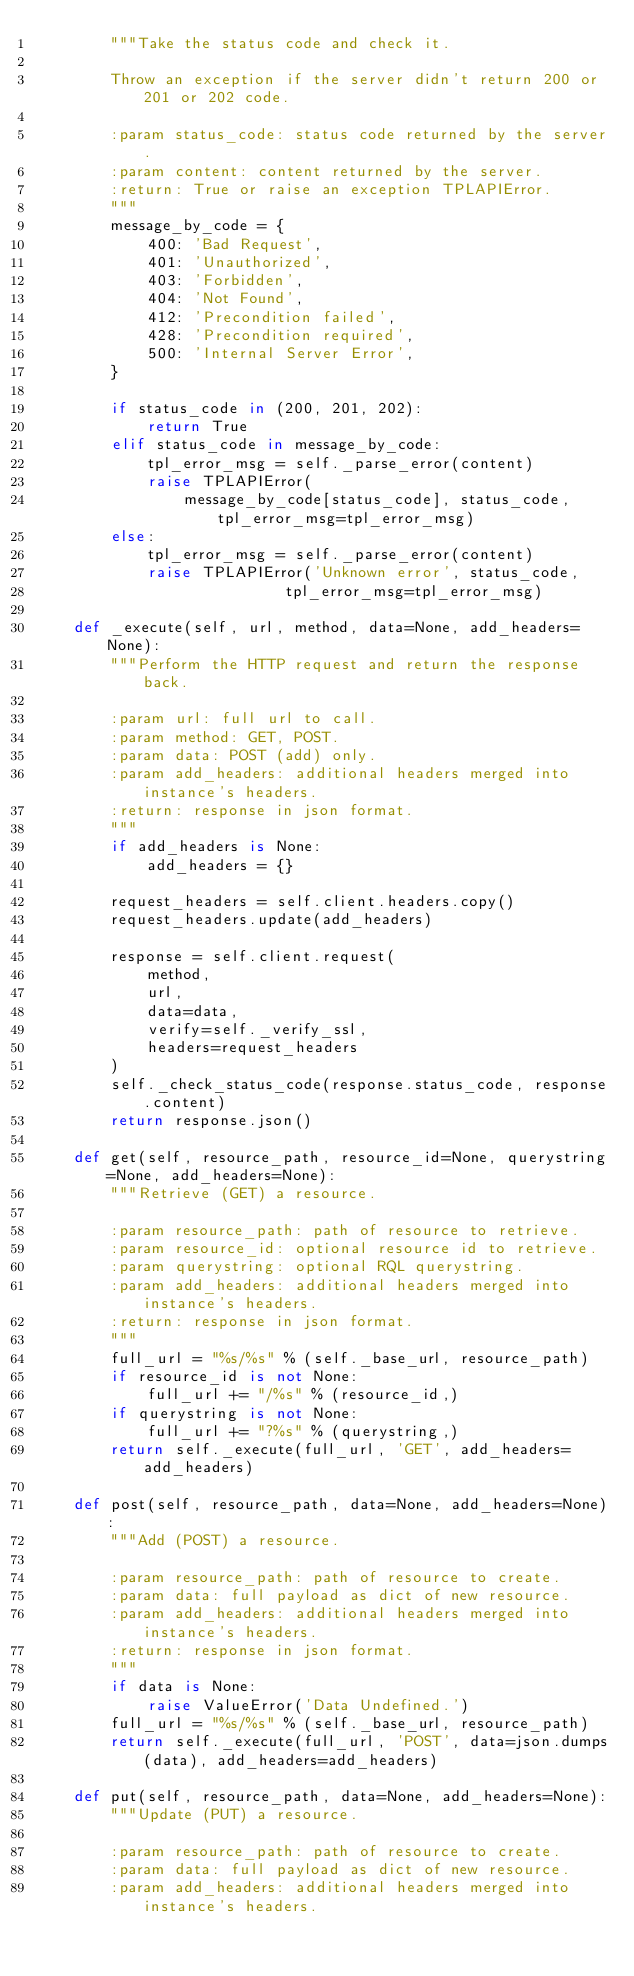<code> <loc_0><loc_0><loc_500><loc_500><_Python_>        """Take the status code and check it.

        Throw an exception if the server didn't return 200 or 201 or 202 code.

        :param status_code: status code returned by the server.
        :param content: content returned by the server.
        :return: True or raise an exception TPLAPIError.
        """
        message_by_code = {
            400: 'Bad Request',
            401: 'Unauthorized',
            403: 'Forbidden',
            404: 'Not Found',
            412: 'Precondition failed',
            428: 'Precondition required',
            500: 'Internal Server Error',
        }

        if status_code in (200, 201, 202):
            return True
        elif status_code in message_by_code:
            tpl_error_msg = self._parse_error(content)
            raise TPLAPIError(
                message_by_code[status_code], status_code, tpl_error_msg=tpl_error_msg)
        else:
            tpl_error_msg = self._parse_error(content)
            raise TPLAPIError('Unknown error', status_code,
                           tpl_error_msg=tpl_error_msg)

    def _execute(self, url, method, data=None, add_headers=None):
        """Perform the HTTP request and return the response back.

        :param url: full url to call.
        :param method: GET, POST.
        :param data: POST (add) only.
        :param add_headers: additional headers merged into instance's headers.
        :return: response in json format.
        """
        if add_headers is None:
            add_headers = {}

        request_headers = self.client.headers.copy()
        request_headers.update(add_headers)

        response = self.client.request(
            method,
            url,
            data=data,
            verify=self._verify_ssl,
            headers=request_headers
        )
        self._check_status_code(response.status_code, response.content)
        return response.json()

    def get(self, resource_path, resource_id=None, querystring=None, add_headers=None):
        """Retrieve (GET) a resource.

        :param resource_path: path of resource to retrieve.
        :param resource_id: optional resource id to retrieve.
        :param querystring: optional RQL querystring.
        :param add_headers: additional headers merged into instance's headers.
        :return: response in json format.
        """
        full_url = "%s/%s" % (self._base_url, resource_path)
        if resource_id is not None:
            full_url += "/%s" % (resource_id,)
        if querystring is not None:
            full_url += "?%s" % (querystring,)
        return self._execute(full_url, 'GET', add_headers=add_headers)

    def post(self, resource_path, data=None, add_headers=None):
        """Add (POST) a resource.

        :param resource_path: path of resource to create.
        :param data: full payload as dict of new resource.
        :param add_headers: additional headers merged into instance's headers.
        :return: response in json format.
        """
        if data is None:
            raise ValueError('Data Undefined.')
        full_url = "%s/%s" % (self._base_url, resource_path)
        return self._execute(full_url, 'POST', data=json.dumps(data), add_headers=add_headers)

    def put(self, resource_path, data=None, add_headers=None):
        """Update (PUT) a resource.

        :param resource_path: path of resource to create.
        :param data: full payload as dict of new resource.
        :param add_headers: additional headers merged into instance's headers.</code> 